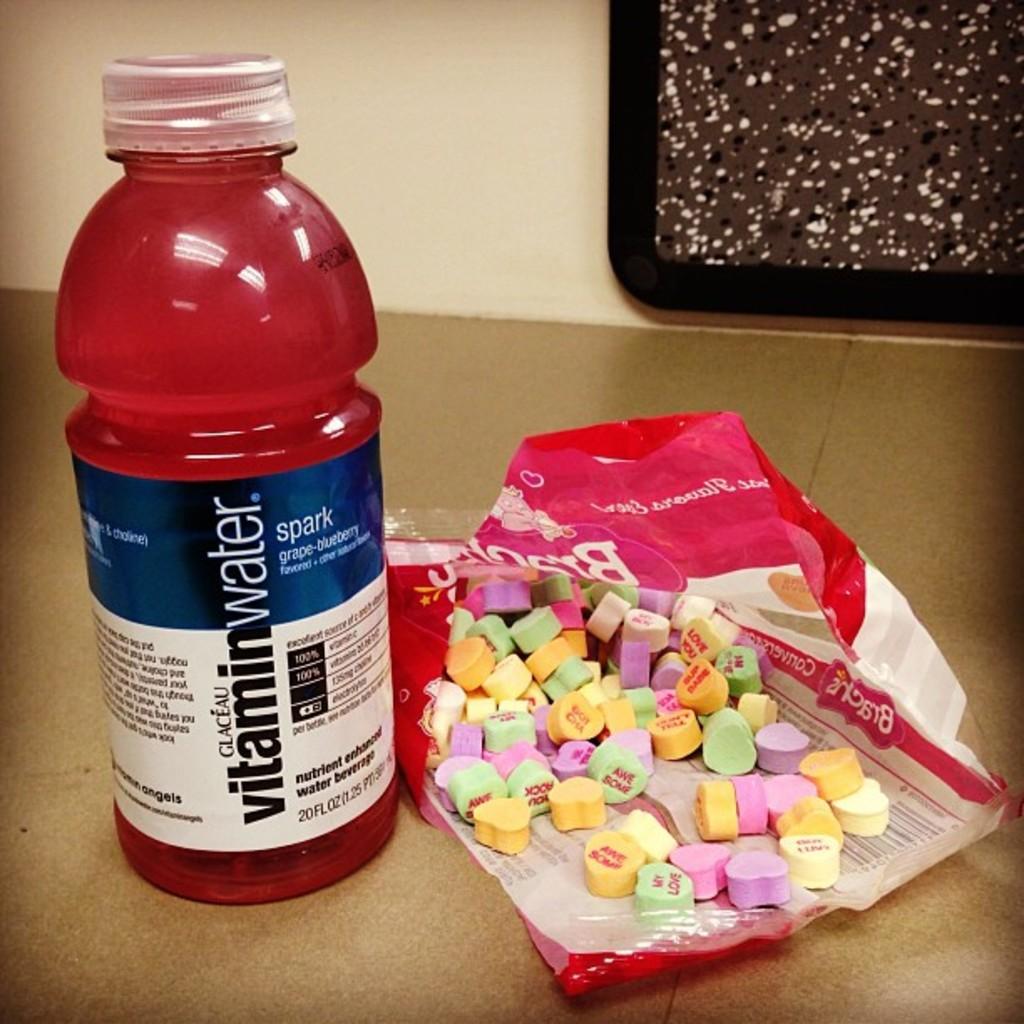What is this drink?
Offer a very short reply. Vitamin water. What flavor is this vitamin water?
Your response must be concise. Grape-blueberry. 